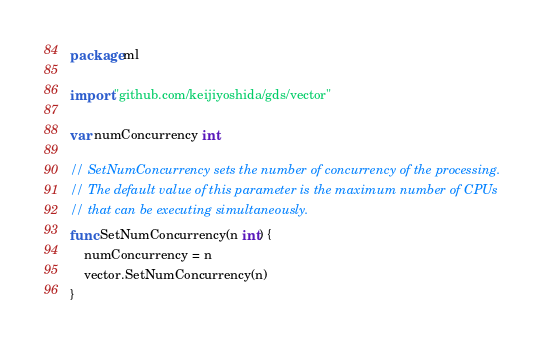<code> <loc_0><loc_0><loc_500><loc_500><_Go_>package ml

import "github.com/keijiyoshida/gds/vector"

var numConcurrency int

// SetNumConcurrency sets the number of concurrency of the processing.
// The default value of this parameter is the maximum number of CPUs
// that can be executing simultaneously.
func SetNumConcurrency(n int) {
	numConcurrency = n
	vector.SetNumConcurrency(n)
}
</code> 